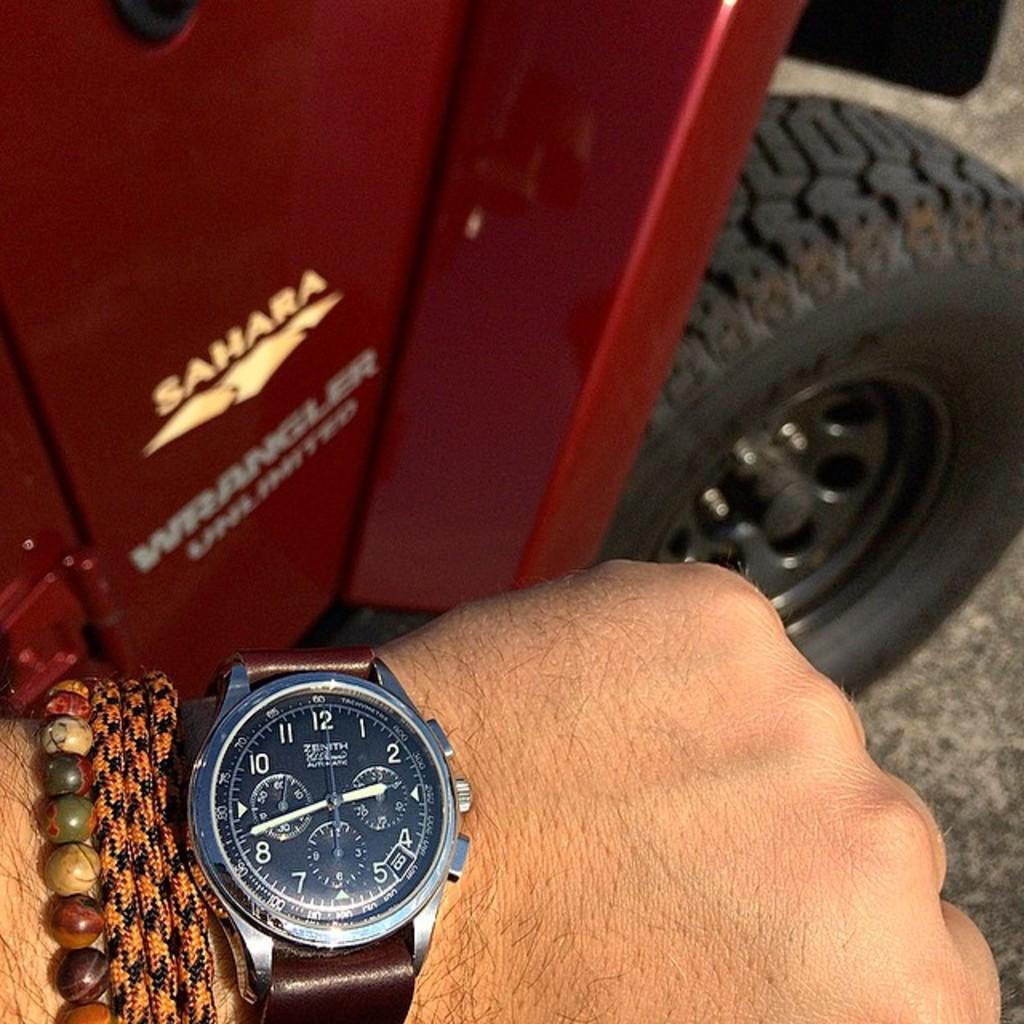What is the time on the watch?
Keep it short and to the point. 2:42. What is the brand name in gold text?
Give a very brief answer. Sahara. 